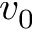Convert formula to latex. <formula><loc_0><loc_0><loc_500><loc_500>v _ { 0 }</formula> 